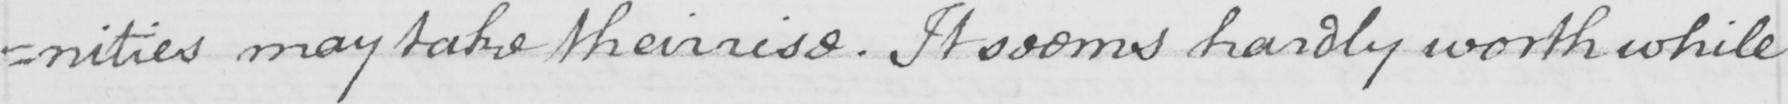What is written in this line of handwriting? =nities may take their rise . It seems hardly worth while 